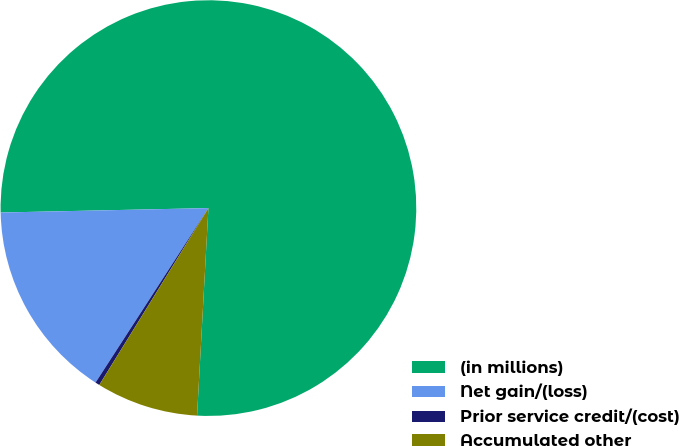<chart> <loc_0><loc_0><loc_500><loc_500><pie_chart><fcel>(in millions)<fcel>Net gain/(loss)<fcel>Prior service credit/(cost)<fcel>Accumulated other<nl><fcel>76.21%<fcel>15.52%<fcel>0.34%<fcel>7.93%<nl></chart> 